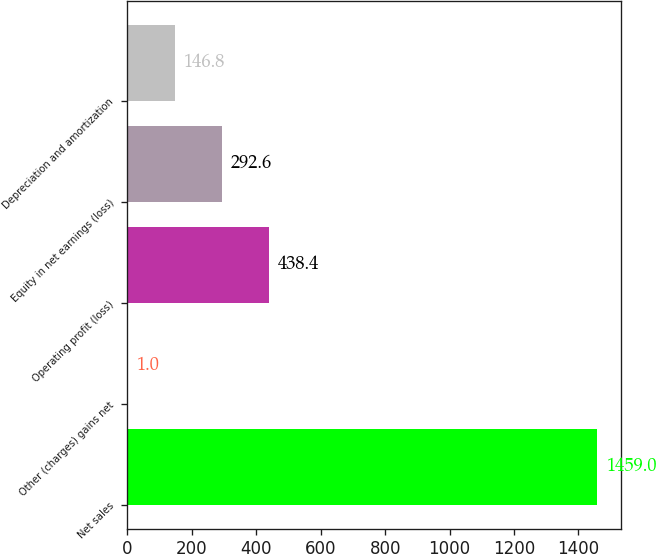Convert chart. <chart><loc_0><loc_0><loc_500><loc_500><bar_chart><fcel>Net sales<fcel>Other (charges) gains net<fcel>Operating profit (loss)<fcel>Equity in net earnings (loss)<fcel>Depreciation and amortization<nl><fcel>1459<fcel>1<fcel>438.4<fcel>292.6<fcel>146.8<nl></chart> 